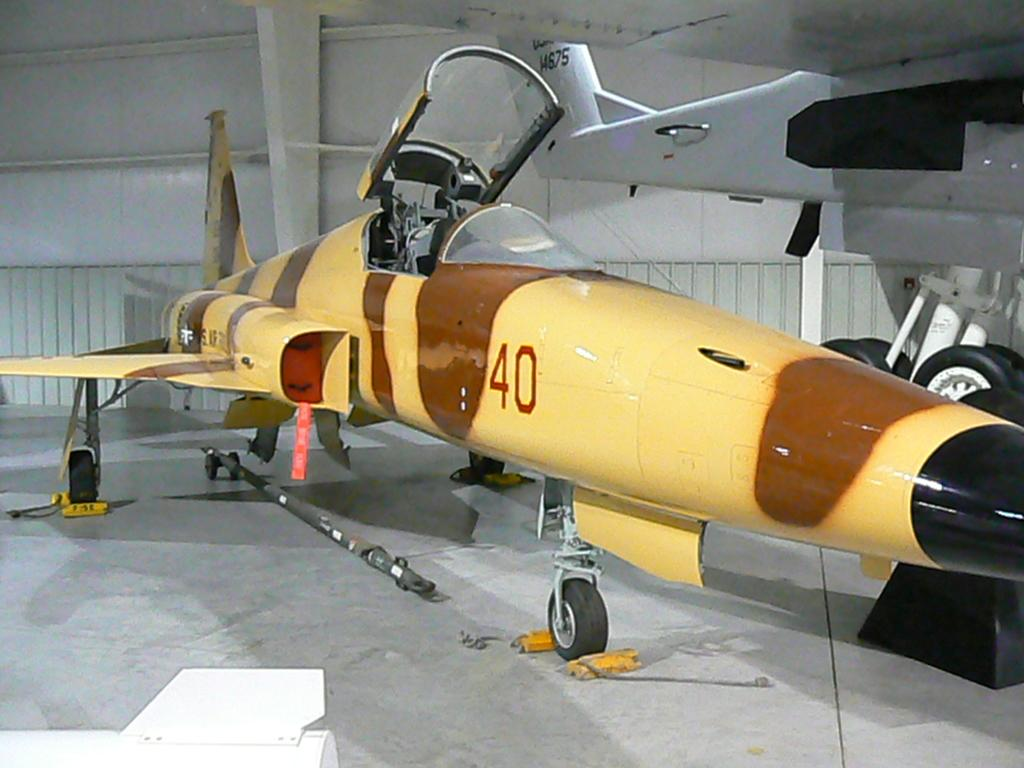Provide a one-sentence caption for the provided image. A yellow and brown plane has the number 40 painted on the side of it. 